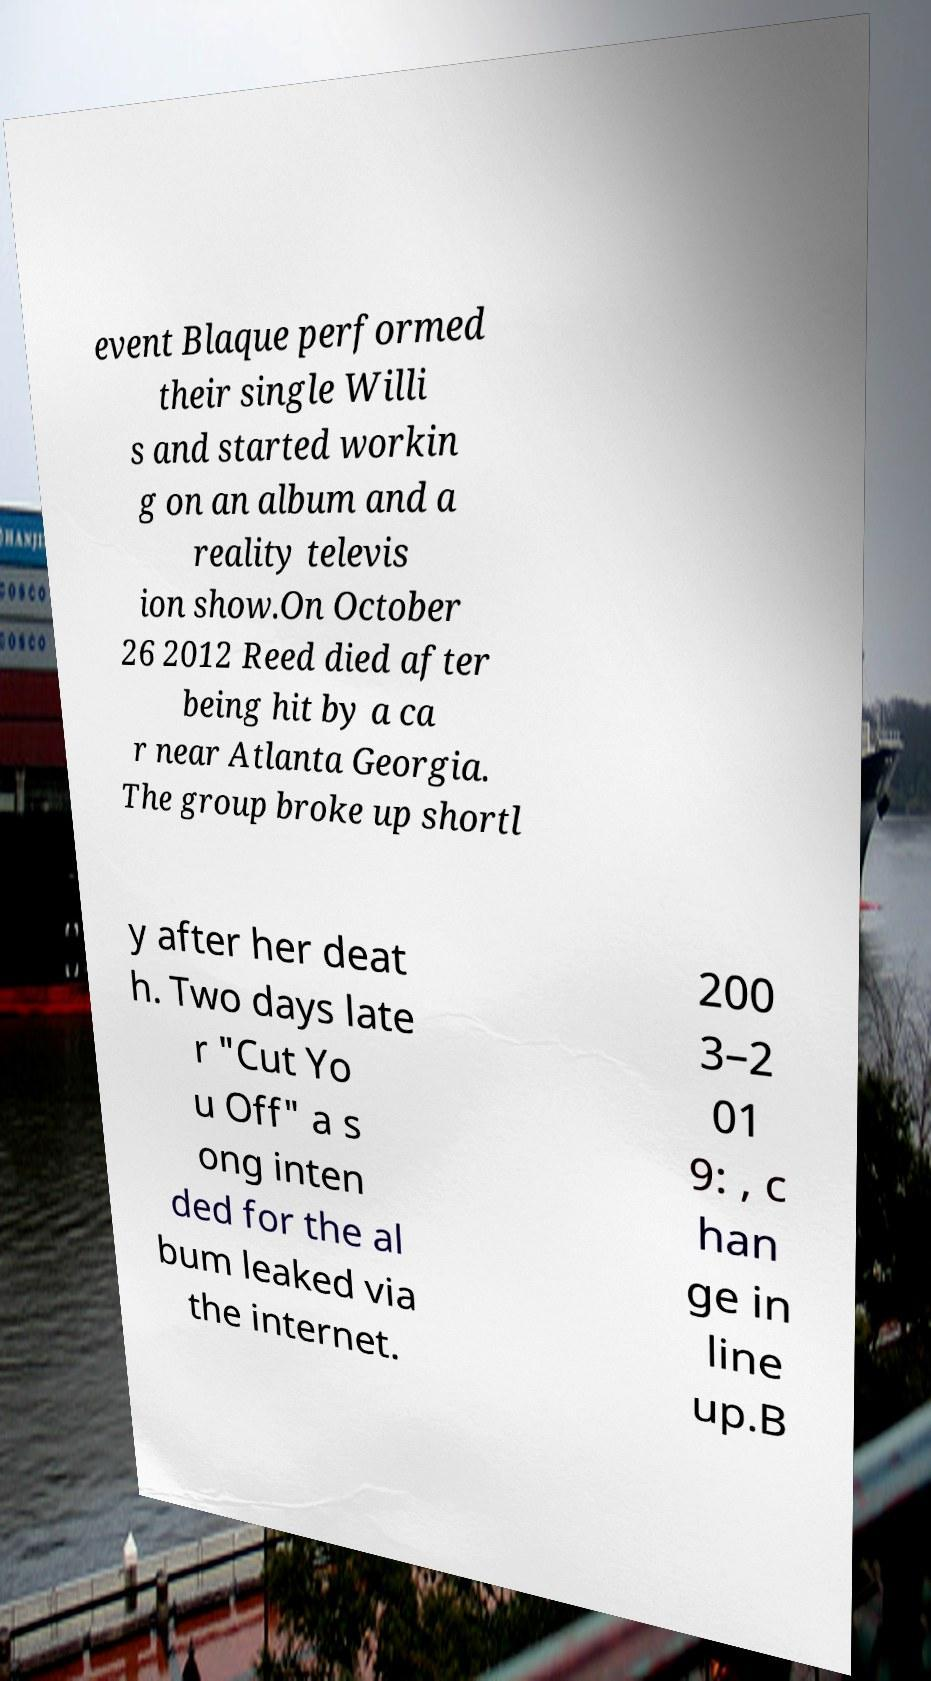Could you assist in decoding the text presented in this image and type it out clearly? event Blaque performed their single Willi s and started workin g on an album and a reality televis ion show.On October 26 2012 Reed died after being hit by a ca r near Atlanta Georgia. The group broke up shortl y after her deat h. Two days late r "Cut Yo u Off" a s ong inten ded for the al bum leaked via the internet. 200 3–2 01 9: , c han ge in line up.B 